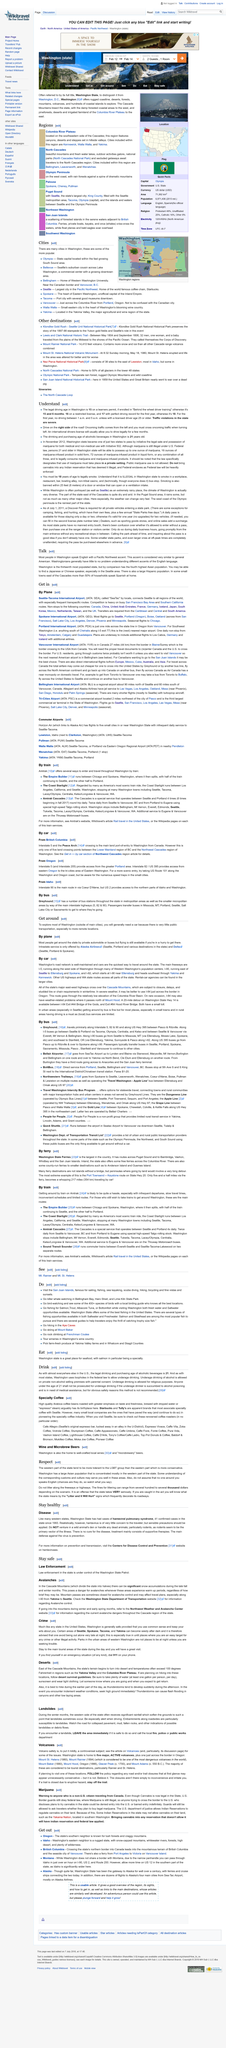Outline some significant characteristics in this image. Seattle, the vibrant city located in the state of Washington, is known for its technology companies, coffee shops, and iconic landmarks such as the Space Needle and the Pike Place Market. According to a recent survey, Washington is the 13th most populous state in America. The state of Washington has the fourth highest Asian population among all the states in the United States. 